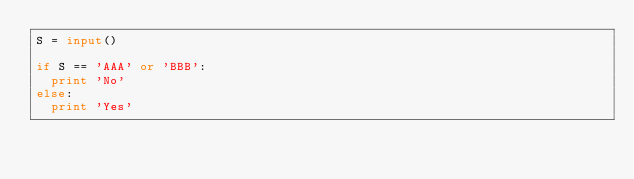Convert code to text. <code><loc_0><loc_0><loc_500><loc_500><_Python_>S = input()
 
if S == 'AAA' or 'BBB':
  print 'No'
else:
  print 'Yes'</code> 